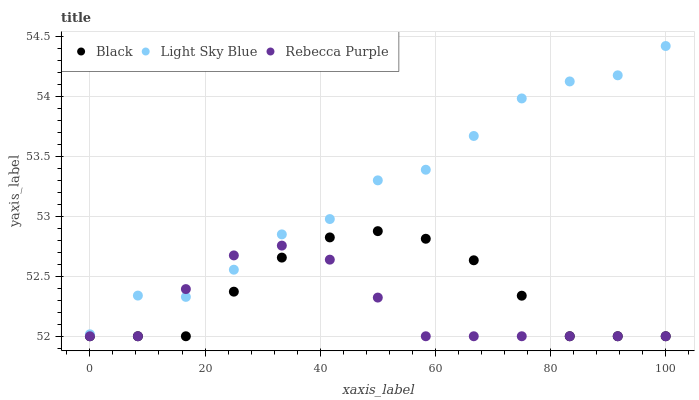Does Rebecca Purple have the minimum area under the curve?
Answer yes or no. Yes. Does Light Sky Blue have the maximum area under the curve?
Answer yes or no. Yes. Does Black have the minimum area under the curve?
Answer yes or no. No. Does Black have the maximum area under the curve?
Answer yes or no. No. Is Black the smoothest?
Answer yes or no. Yes. Is Light Sky Blue the roughest?
Answer yes or no. Yes. Is Rebecca Purple the smoothest?
Answer yes or no. No. Is Rebecca Purple the roughest?
Answer yes or no. No. Does Black have the lowest value?
Answer yes or no. Yes. Does Light Sky Blue have the highest value?
Answer yes or no. Yes. Does Black have the highest value?
Answer yes or no. No. Is Black less than Light Sky Blue?
Answer yes or no. Yes. Is Light Sky Blue greater than Black?
Answer yes or no. Yes. Does Black intersect Rebecca Purple?
Answer yes or no. Yes. Is Black less than Rebecca Purple?
Answer yes or no. No. Is Black greater than Rebecca Purple?
Answer yes or no. No. Does Black intersect Light Sky Blue?
Answer yes or no. No. 